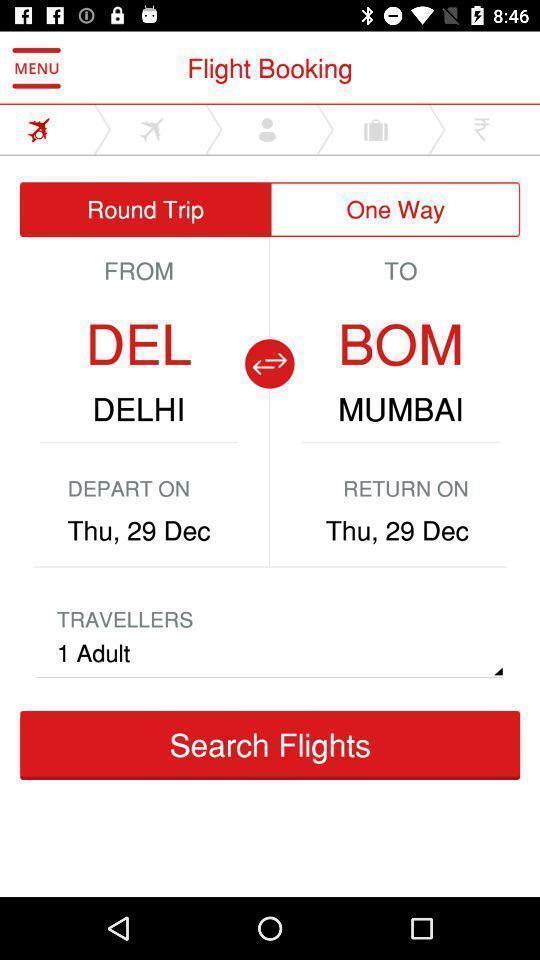Describe the key features of this screenshot. Search page to find the flight with the following details. 